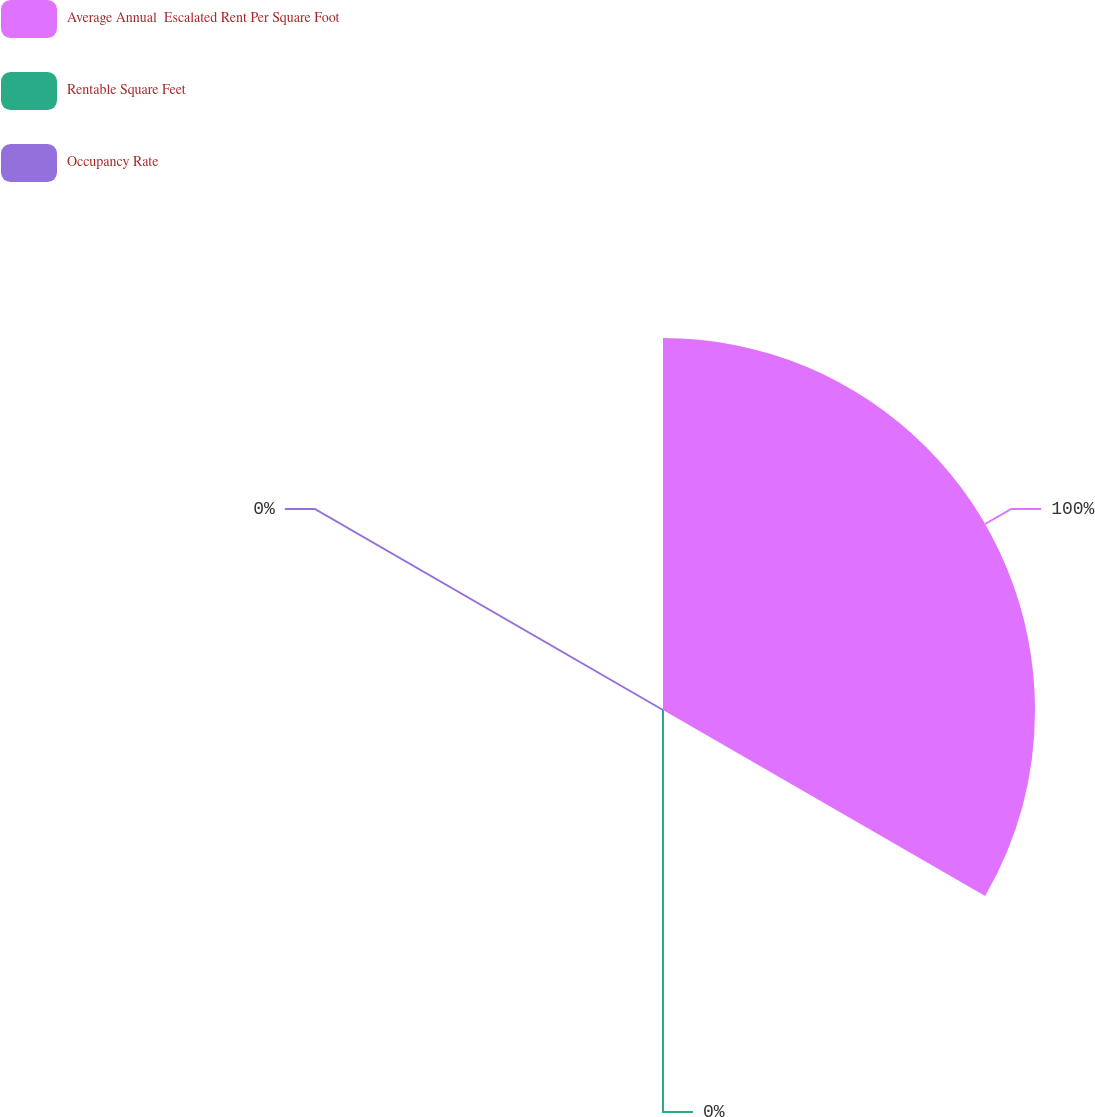<chart> <loc_0><loc_0><loc_500><loc_500><pie_chart><fcel>Average Annual  Escalated Rent Per Square Foot<fcel>Rentable Square Feet<fcel>Occupancy Rate<nl><fcel>100.0%<fcel>0.0%<fcel>0.0%<nl></chart> 